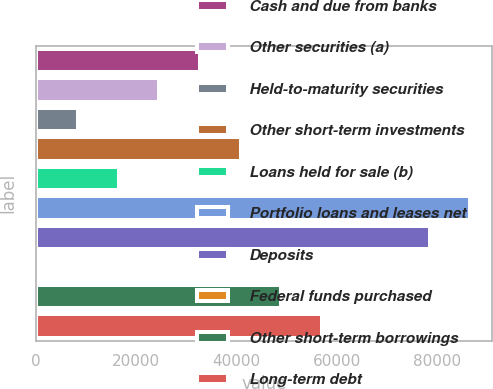Convert chart to OTSL. <chart><loc_0><loc_0><loc_500><loc_500><bar_chart><fcel>Cash and due from banks<fcel>Other securities (a)<fcel>Held-to-maturity securities<fcel>Other short-term investments<fcel>Loans held for sale (b)<fcel>Portfolio loans and leases net<fcel>Deposits<fcel>Federal funds purchased<fcel>Other short-term borrowings<fcel>Long-term debt<nl><fcel>32711.8<fcel>24605.6<fcel>8393.2<fcel>40818<fcel>16499.4<fcel>86719.2<fcel>78613<fcel>287<fcel>48924.2<fcel>57030.4<nl></chart> 